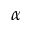<formula> <loc_0><loc_0><loc_500><loc_500>\alpha</formula> 